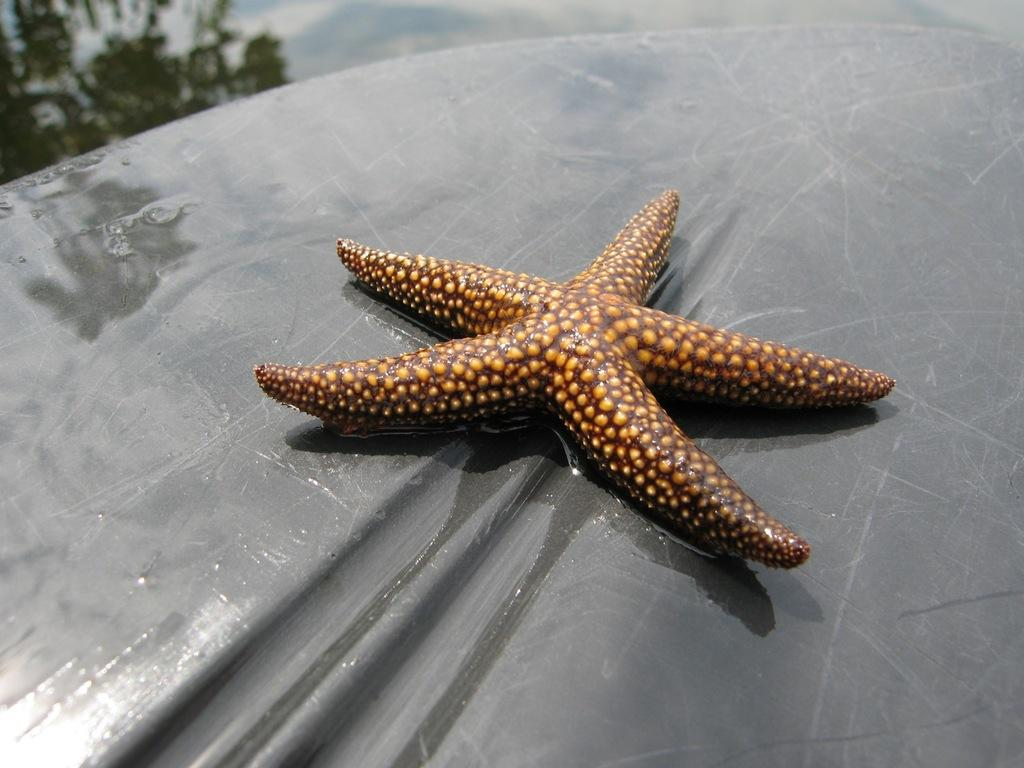What is the main subject of the image? The main subject of the image is a starfish. Can you describe the position or location of the starfish in the image? The starfish is on some object. What type of alarm can be heard going off in the image? There is no alarm present in the image, as it features a starfish on some object. 